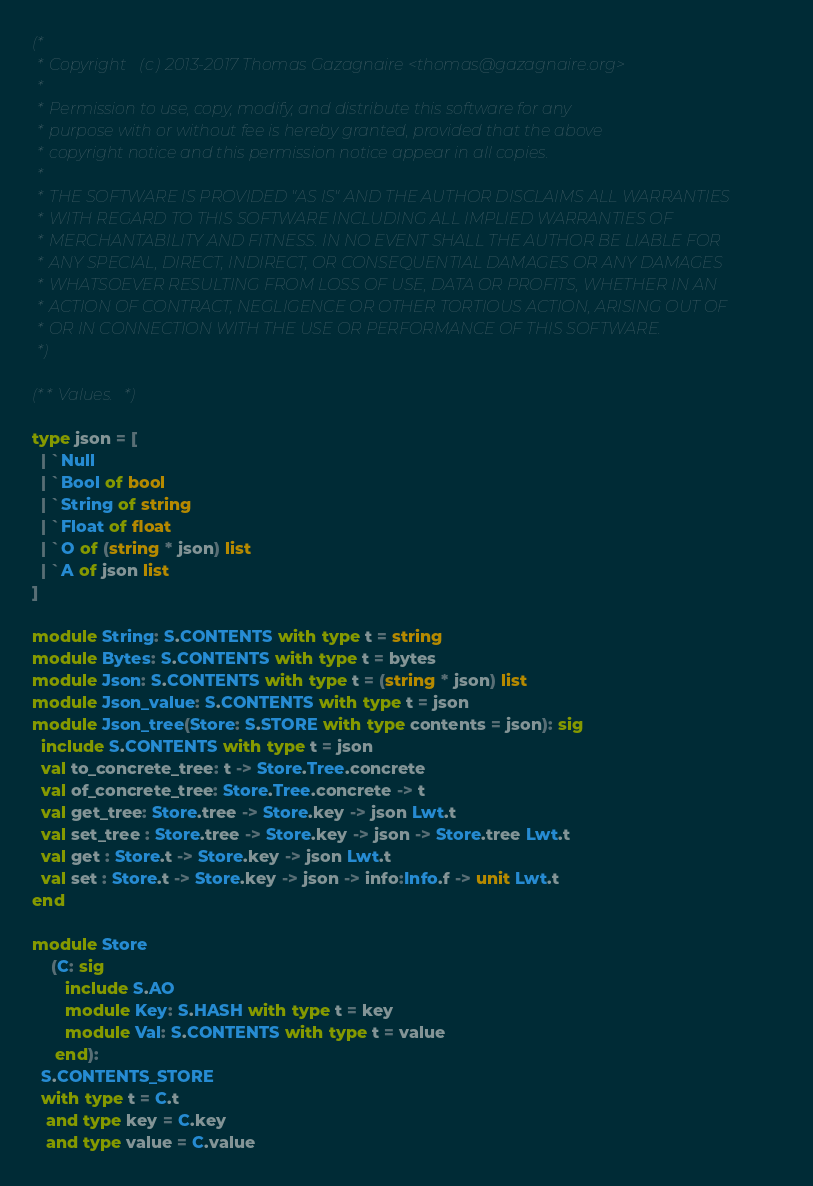<code> <loc_0><loc_0><loc_500><loc_500><_OCaml_>(*
 * Copyright (c) 2013-2017 Thomas Gazagnaire <thomas@gazagnaire.org>
 *
 * Permission to use, copy, modify, and distribute this software for any
 * purpose with or without fee is hereby granted, provided that the above
 * copyright notice and this permission notice appear in all copies.
 *
 * THE SOFTWARE IS PROVIDED "AS IS" AND THE AUTHOR DISCLAIMS ALL WARRANTIES
 * WITH REGARD TO THIS SOFTWARE INCLUDING ALL IMPLIED WARRANTIES OF
 * MERCHANTABILITY AND FITNESS. IN NO EVENT SHALL THE AUTHOR BE LIABLE FOR
 * ANY SPECIAL, DIRECT, INDIRECT, OR CONSEQUENTIAL DAMAGES OR ANY DAMAGES
 * WHATSOEVER RESULTING FROM LOSS OF USE, DATA OR PROFITS, WHETHER IN AN
 * ACTION OF CONTRACT, NEGLIGENCE OR OTHER TORTIOUS ACTION, ARISING OUT OF
 * OR IN CONNECTION WITH THE USE OR PERFORMANCE OF THIS SOFTWARE.
 *)

(** Values. *)

type json = [
  | `Null
  | `Bool of bool
  | `String of string
  | `Float of float
  | `O of (string * json) list
  | `A of json list
]

module String: S.CONTENTS with type t = string
module Bytes: S.CONTENTS with type t = bytes
module Json: S.CONTENTS with type t = (string * json) list
module Json_value: S.CONTENTS with type t = json
module Json_tree(Store: S.STORE with type contents = json): sig
  include S.CONTENTS with type t = json
  val to_concrete_tree: t -> Store.Tree.concrete
  val of_concrete_tree: Store.Tree.concrete -> t
  val get_tree: Store.tree -> Store.key -> json Lwt.t
  val set_tree : Store.tree -> Store.key -> json -> Store.tree Lwt.t
  val get : Store.t -> Store.key -> json Lwt.t
  val set : Store.t -> Store.key -> json -> info:Info.f -> unit Lwt.t
end

module Store
    (C: sig
       include S.AO
       module Key: S.HASH with type t = key
       module Val: S.CONTENTS with type t = value
     end):
  S.CONTENTS_STORE
  with type t = C.t
   and type key = C.key
   and type value = C.value
</code> 